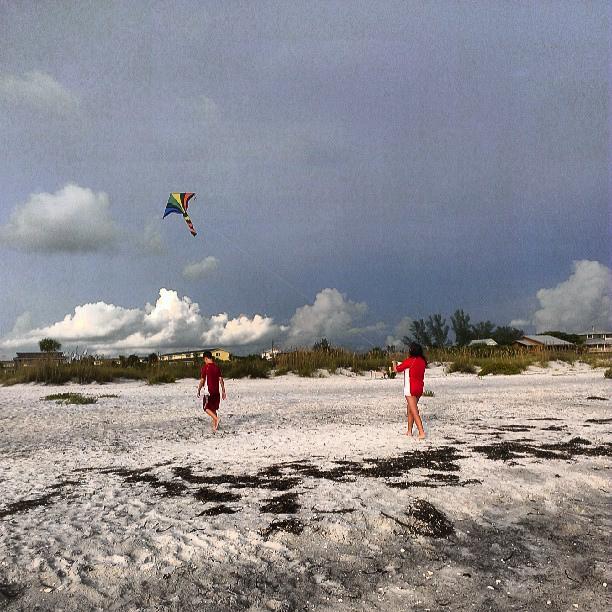How much dry land is shown?
Short answer required. Lot. Is either figure wearing long pants?
Concise answer only. No. What is the forecast like?
Keep it brief. Cloudy. Which person is controlling the kite?
Answer briefly. Woman. 